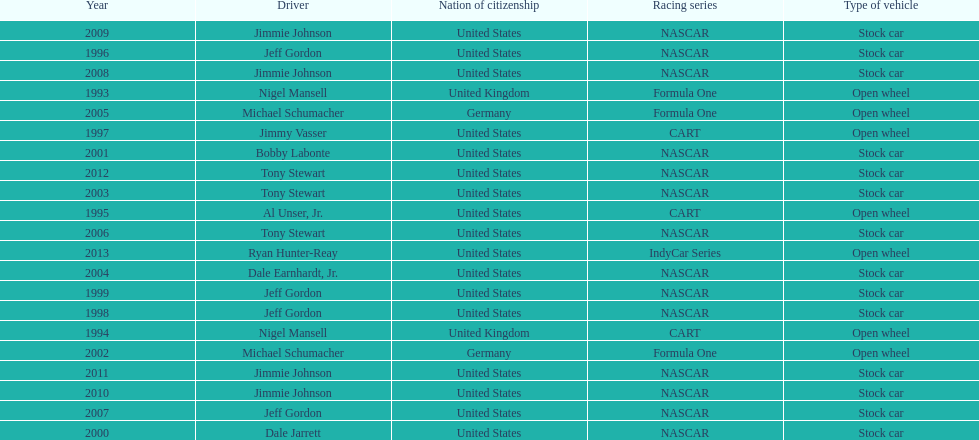Which driver won espy awards 11 years apart from each other? Jeff Gordon. 